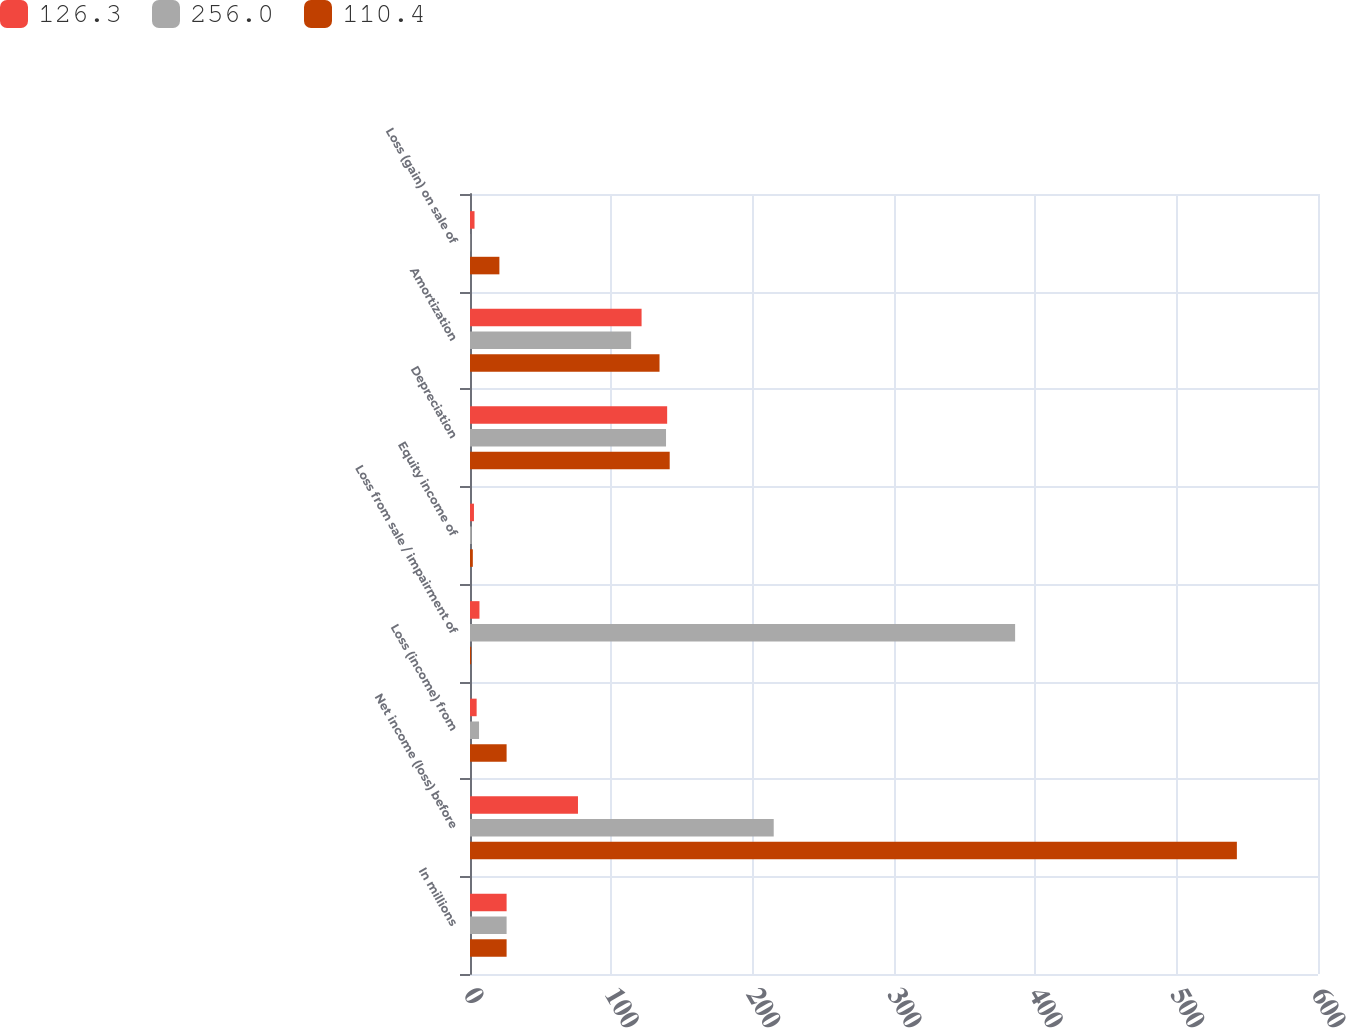Convert chart to OTSL. <chart><loc_0><loc_0><loc_500><loc_500><stacked_bar_chart><ecel><fcel>In millions<fcel>Net income (loss) before<fcel>Loss (income) from<fcel>Loss from sale / impairment of<fcel>Equity income of<fcel>Depreciation<fcel>Amortization<fcel>Loss (gain) on sale of<nl><fcel>126.3<fcel>25.9<fcel>76.4<fcel>4.7<fcel>6.7<fcel>2.8<fcel>139.5<fcel>121.4<fcel>3.2<nl><fcel>256<fcel>25.9<fcel>214.9<fcel>6.4<fcel>385.7<fcel>1.2<fcel>138.7<fcel>114<fcel>0.2<nl><fcel>110.4<fcel>25.9<fcel>542.6<fcel>25.9<fcel>0.8<fcel>2<fcel>141.3<fcel>134.1<fcel>20.8<nl></chart> 